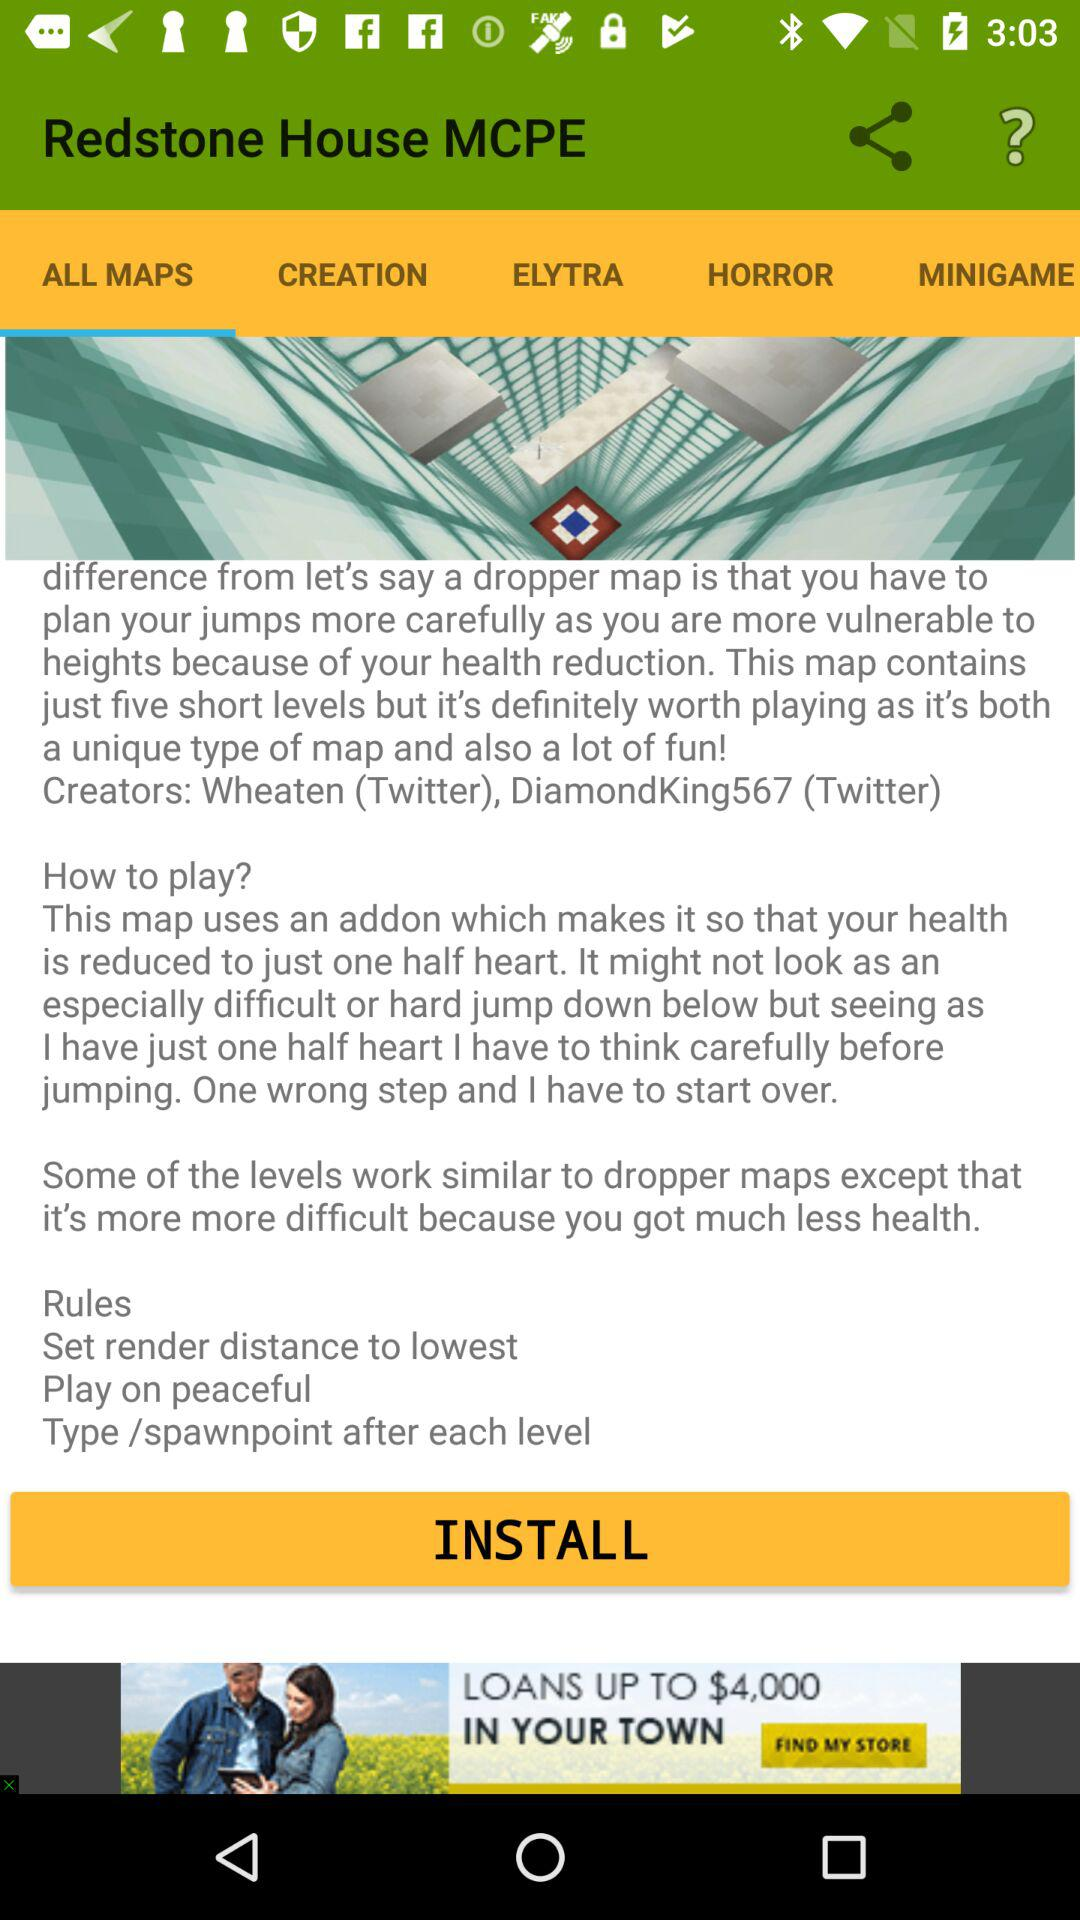What is the name of the application? The name of the application is "Redstone House MCPE". 